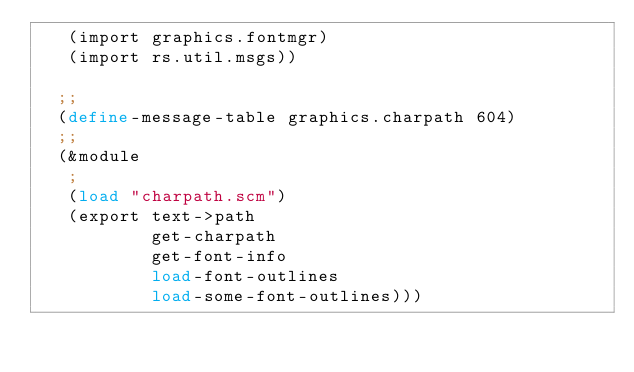<code> <loc_0><loc_0><loc_500><loc_500><_Scheme_>   (import graphics.fontmgr)
   (import rs.util.msgs))
  
  ;;
  (define-message-table graphics.charpath 604)
  ;;
  (&module
   ;
   (load "charpath.scm")
   (export text->path
           get-charpath
           get-font-info
           load-font-outlines
           load-some-font-outlines)))
</code> 